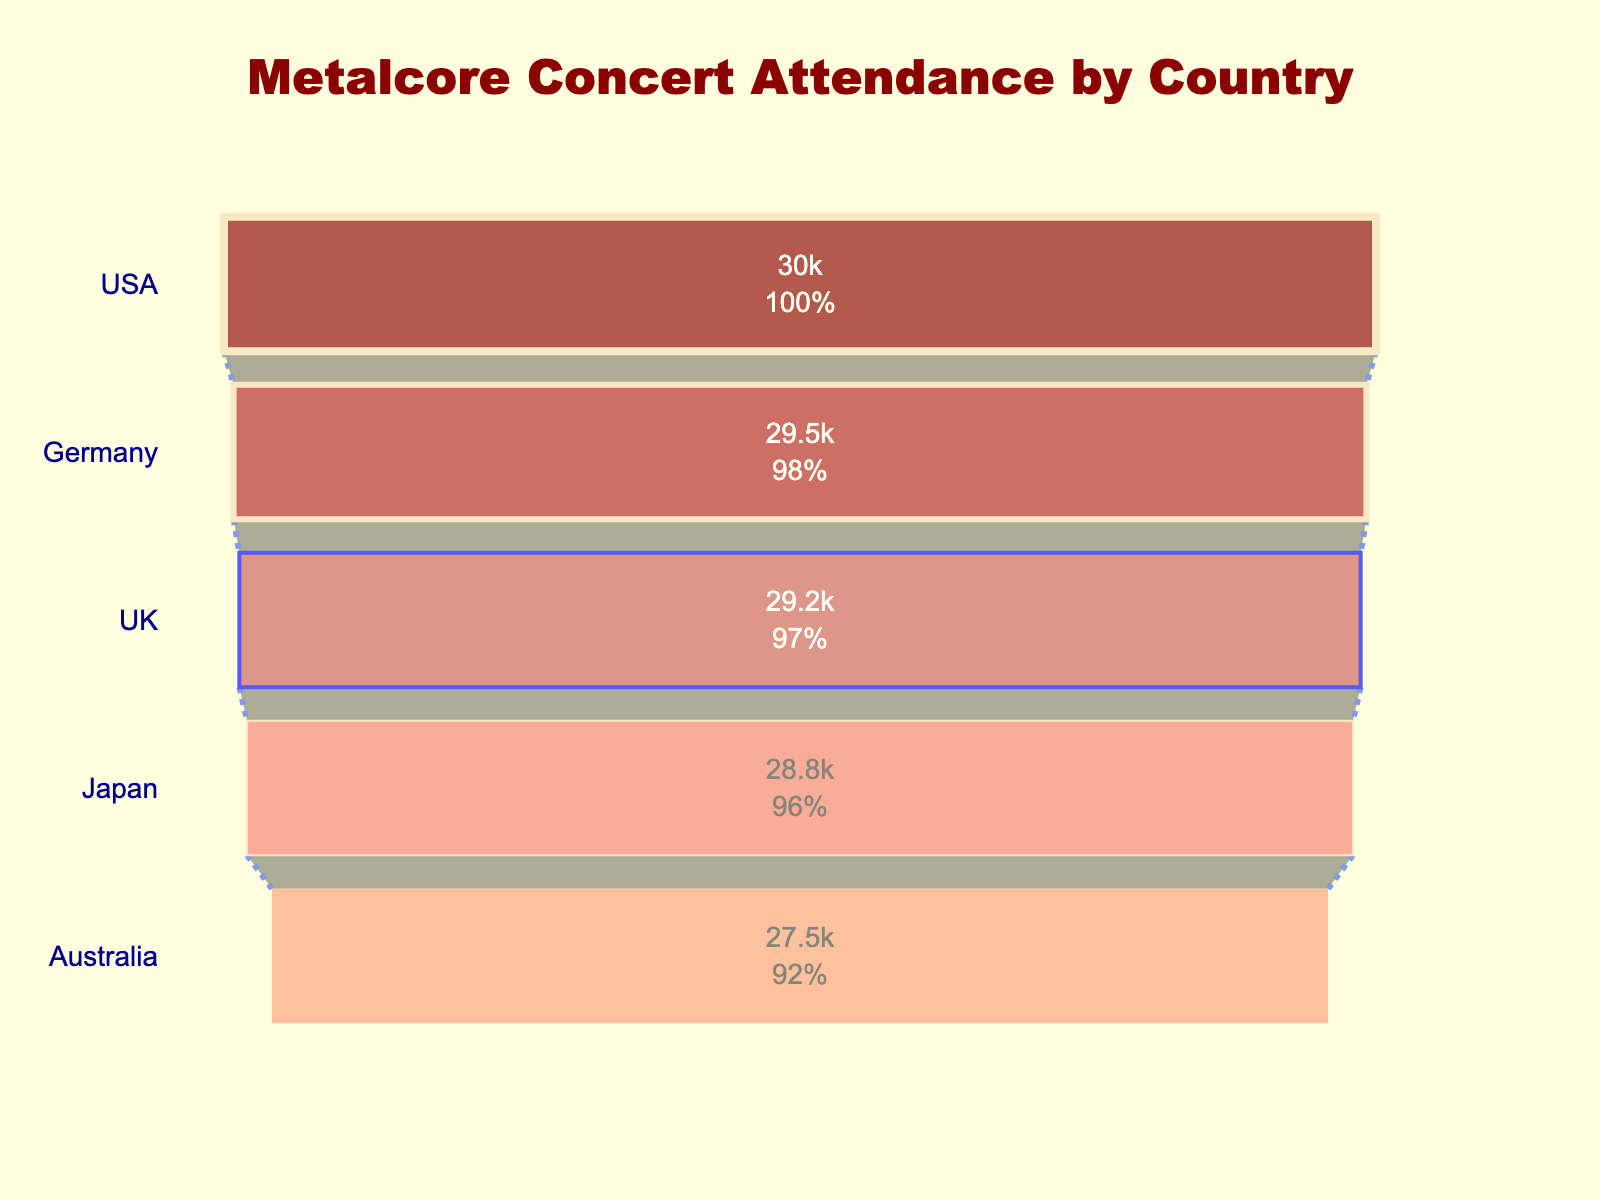What's the title of the funnel chart? The title is prominently located at the top-center of the chart. It reads "Metalcore Concert Attendance by Country".
Answer: Metalcore Concert Attendance by Country What country had the highest attendance for metalcore concerts? In the funnel chart, the country with the greatest attendance is at the widest part at the top. It is the USA.
Answer: USA What's the attendance difference between the USA and Japan? The attendance for the USA is 30,000 and for Japan, it is 28,800. The difference is calculated by subtracting Japan's attendance from the USA's attendance: 30,000 - 28,800 = 1,200.
Answer: 1,200 Which country has the lowest attendance among the ones listed? The funnel chart narrows down towards the bottom indicating lower attendance. The country with the smallest value is Australia, with 27,500.
Answer: Australia How do Germany and the UK compare in terms of concert attendance? By comparing their positions and values on the funnel chart, Germany has 29,500 while the UK has 29,200. Germany has a slightly higher attendance than the UK.
Answer: Germany has a higher attendance What is the total attendance for metalcore concerts across all five countries? Adding up the attendance figures from each country: 30,000 (USA) + 29,500 (Germany) + 28,800 (Japan) + 27,500 (Australia) + 29,200 (UK) = 145,000.
Answer: 145,000 What percentage of the total attendance does Germany contribute? First, compute the total attendance (145,000). Then, calculate Germany's percentage: (29,500 / 145,000) * 100%. This equals approximately 20.34%.
Answer: 20.34% Which country has an attendance closest to the average attendance across all countries? Calculate the average attendance: 145,000 / 5 = 29,000. Comparing each value, Germany with 29,500 is closest to the average of 29,000.
Answer: Germany What is the median attendance value among the countries? Arrange the attendance values in order: 27,500, 28,800, 29,200, 29,500, 30,000. The middle value in this sorted list is 29,200.
Answer: 29,200 What color represents the highest attended country in the funnel chart? The funnel chart assigns colors to each country. The widest section at the top, representing the USA, is colored the darker shade of red (#8B0000).
Answer: Dark red 